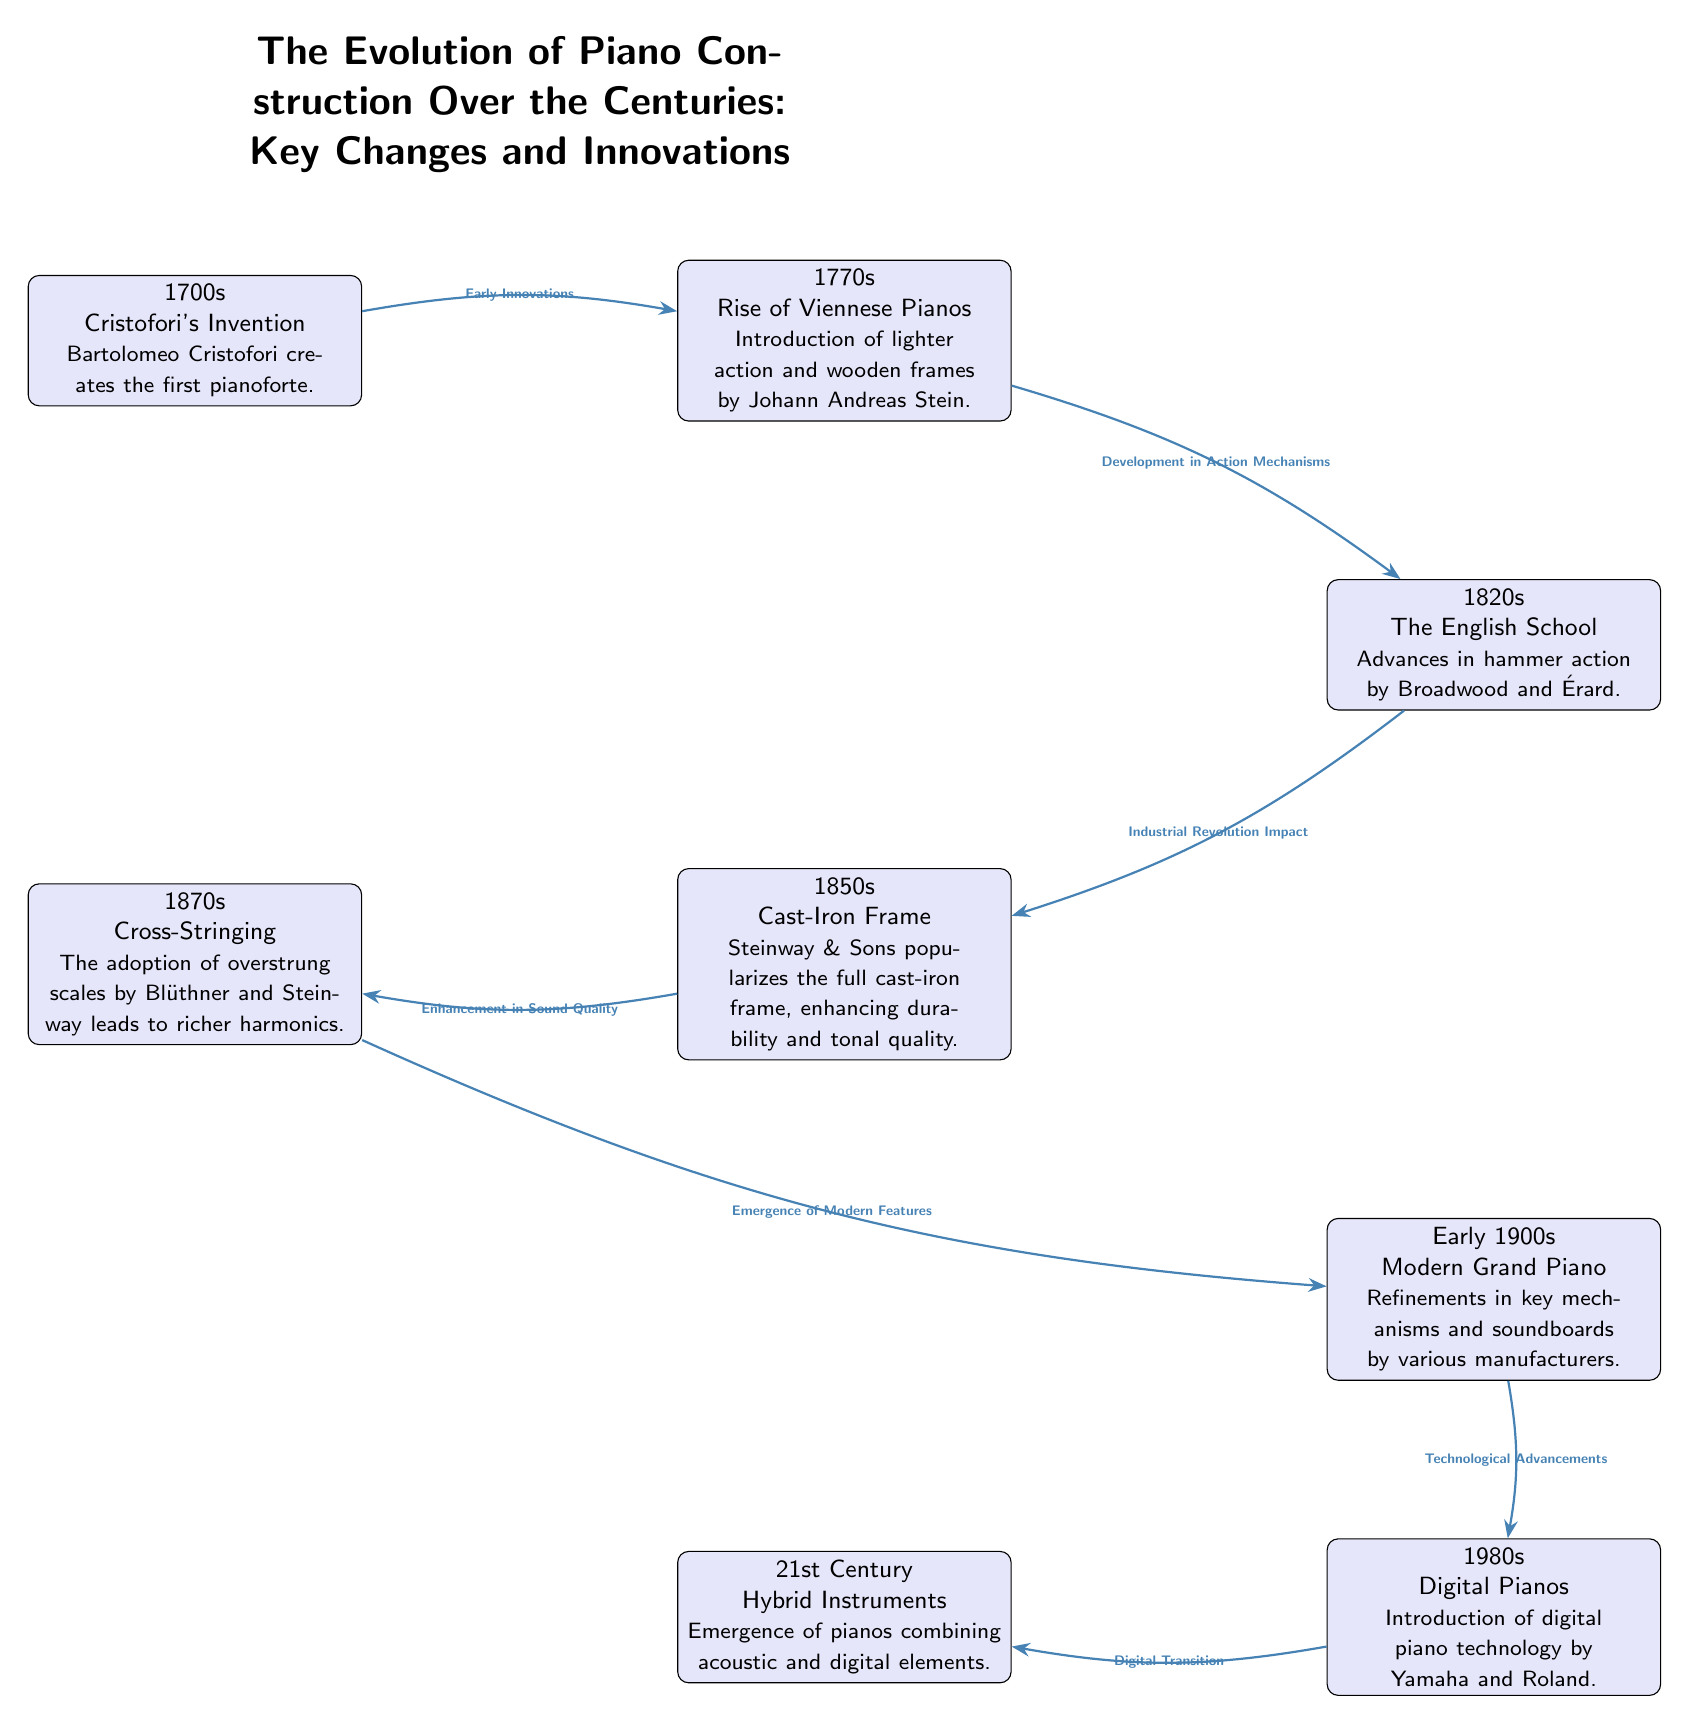What decade did Bartolomeo Cristofori invent the pianoforte? The diagram indicates that the first pianoforte was created by Bartolomeo Cristofori in the 1700s.
Answer: 1700s Which innovation is associated with the 1850s? From the diagram, the 1850s highlights the introduction of the full cast-iron frame by Steinway & Sons, enhancing both durability and tonal quality.
Answer: Cast-Iron Frame How many key innovations are displayed in the diagram? By examining the diagram, we can count the nodes that represent key innovations, which totals to 7 notable innovations listed across different decades.
Answer: 7 What is the relationship between the 1770s and the 1820s innovations? The diagram illustrates that the 1770s introduced developments in action mechanisms that led to further advances in hammer action in the 1820s, indicating a direct progression of innovation between these decades.
Answer: Development in Action Mechanisms What significant change does the "Modern Grand Piano" relate to? The early 1900s’ "Modern Grand Piano" connects to the innovations from various manufacturers, focusing on refinements in key mechanisms and soundboards, thereby indicating ongoing evolution in piano design.
Answer: Technological Advancements Which company popularized the full cast-iron frame? According to the diagram, that innovation is credited to Steinway & Sons in the 1850s.
Answer: Steinway & Sons What is the time period of the introduction of digital piano technology? The diagram specifies that digital piano technology was introduced in the 1980s by brands like Yamaha and Roland.
Answer: 1980s How do the 1870s innovations enhance sound quality? The 1870s focused on the adoption of overstrung scales, which enhanced the richness of harmonics, indicating a significant improvement in sound quality during that decade.
Answer: Overstrung Scales What decade marks the emergence of hybrid instruments? The diagram states that the 21st century marks the emergence of hybrid instruments that combine both acoustic and digital elements.
Answer: 21st Century 